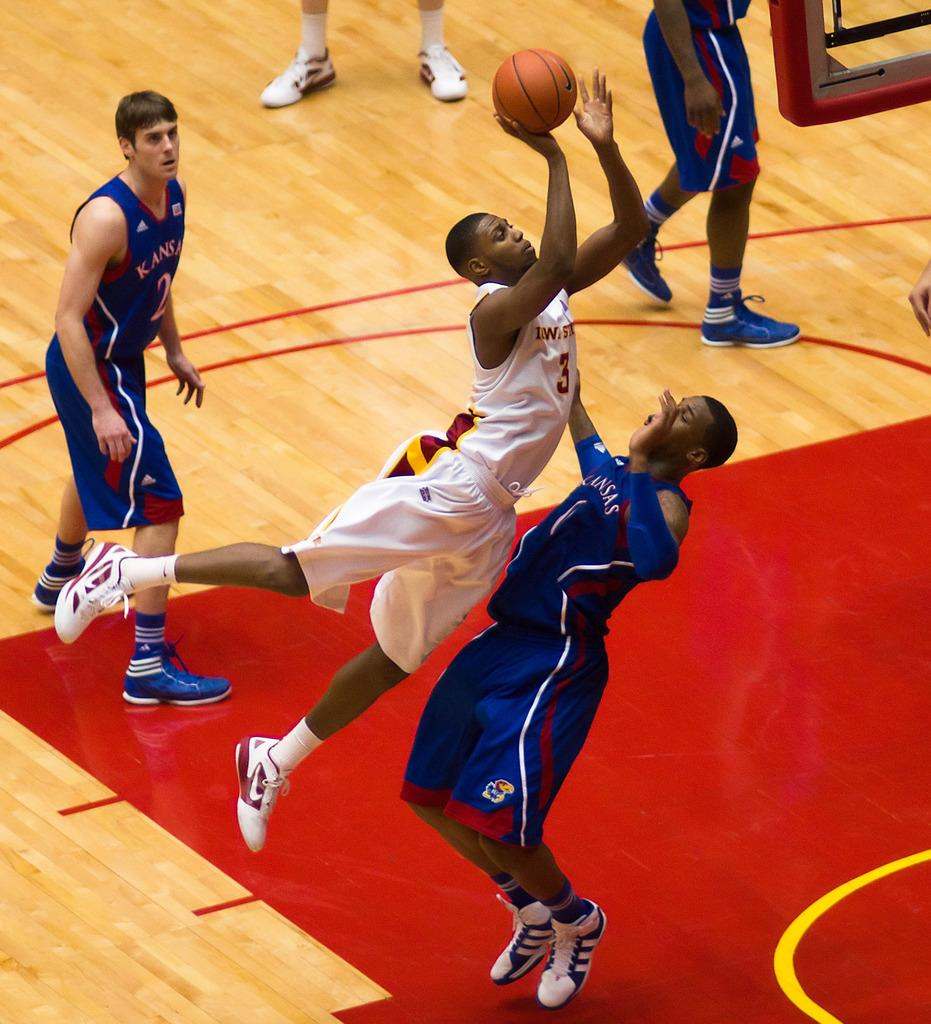Who are the individuals in the image? There are people in the image. What are the people wearing? The people are wearing jerseys. What activity are the people engaged in? The people are playing basketball. Where is the basketball game taking place? The basketball game is taking place in a playground. What is the name of the guitar being played by one of the people in the image? There is no guitar present in the image; the people are playing basketball. 